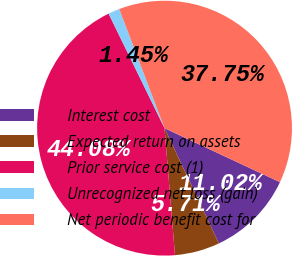<chart> <loc_0><loc_0><loc_500><loc_500><pie_chart><fcel>Interest cost<fcel>Expected return on assets<fcel>Prior service cost (1)<fcel>Unrecognized net loss (gain)<fcel>Net periodic benefit cost for<nl><fcel>11.02%<fcel>5.71%<fcel>44.08%<fcel>1.45%<fcel>37.75%<nl></chart> 